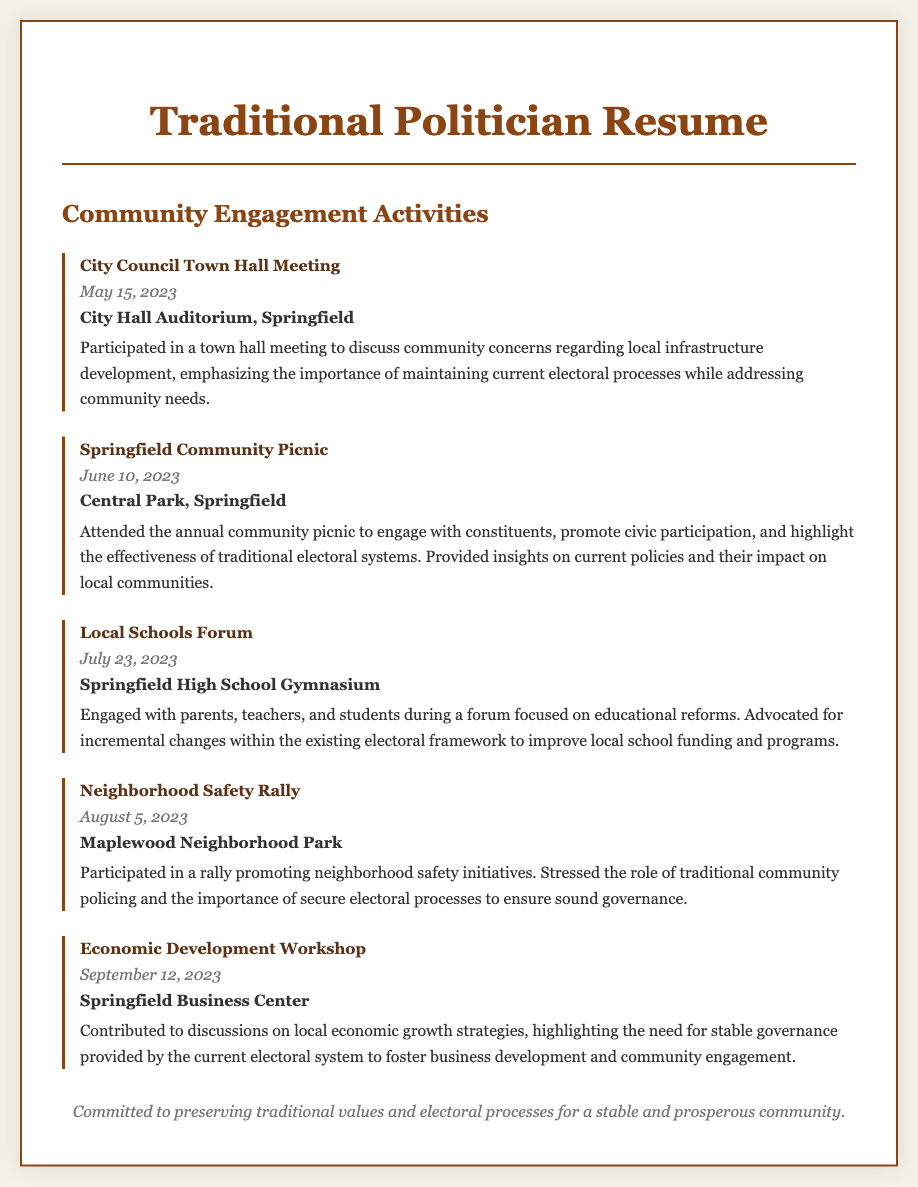What was the date of the City Council Town Hall Meeting? The document lists the date for the City Council Town Hall Meeting as May 15, 2023.
Answer: May 15, 2023 Where was the Springfield Community Picnic held? The location for the Springfield Community Picnic is specified as Central Park, Springfield.
Answer: Central Park, Springfield Which event focused on local educational issues? The Local Schools Forum was focused on educational reforms.
Answer: Local Schools Forum What type of initiative was promoted at the Neighborhood Safety Rally? The Neighborhood Safety Rally promoted neighborhood safety initiatives.
Answer: Neighborhood safety initiatives In which month did the Economic Development Workshop take place? The Economic Development Workshop occurred in September.
Answer: September What is the main emphasis of the politician during the town hall meeting? The politician emphasized maintaining current electoral processes while addressing community needs during the town hall meeting.
Answer: Maintaining current electoral processes How many community engagement activities are listed in the document? The document details a total of five community engagement activities.
Answer: Five What is the overarching theme of the politician's community engagement activities? The overarching theme highlights the effectiveness of traditional electoral systems.
Answer: Effectiveness of traditional electoral systems What is the location of the Local Schools Forum? The Local Schools Forum took place at Springfield High School Gymnasium.
Answer: Springfield High School Gymnasium 